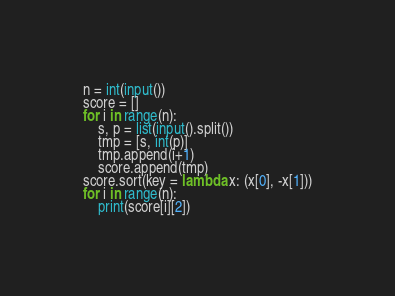Convert code to text. <code><loc_0><loc_0><loc_500><loc_500><_Python_>n = int(input())
score = []
for i in range(n):
    s, p = list(input().split())
    tmp = [s, int(p)]
    tmp.append(i+1)
    score.append(tmp)
score.sort(key = lambda x: (x[0], -x[1]))
for i in range(n):
    print(score[i][2])</code> 